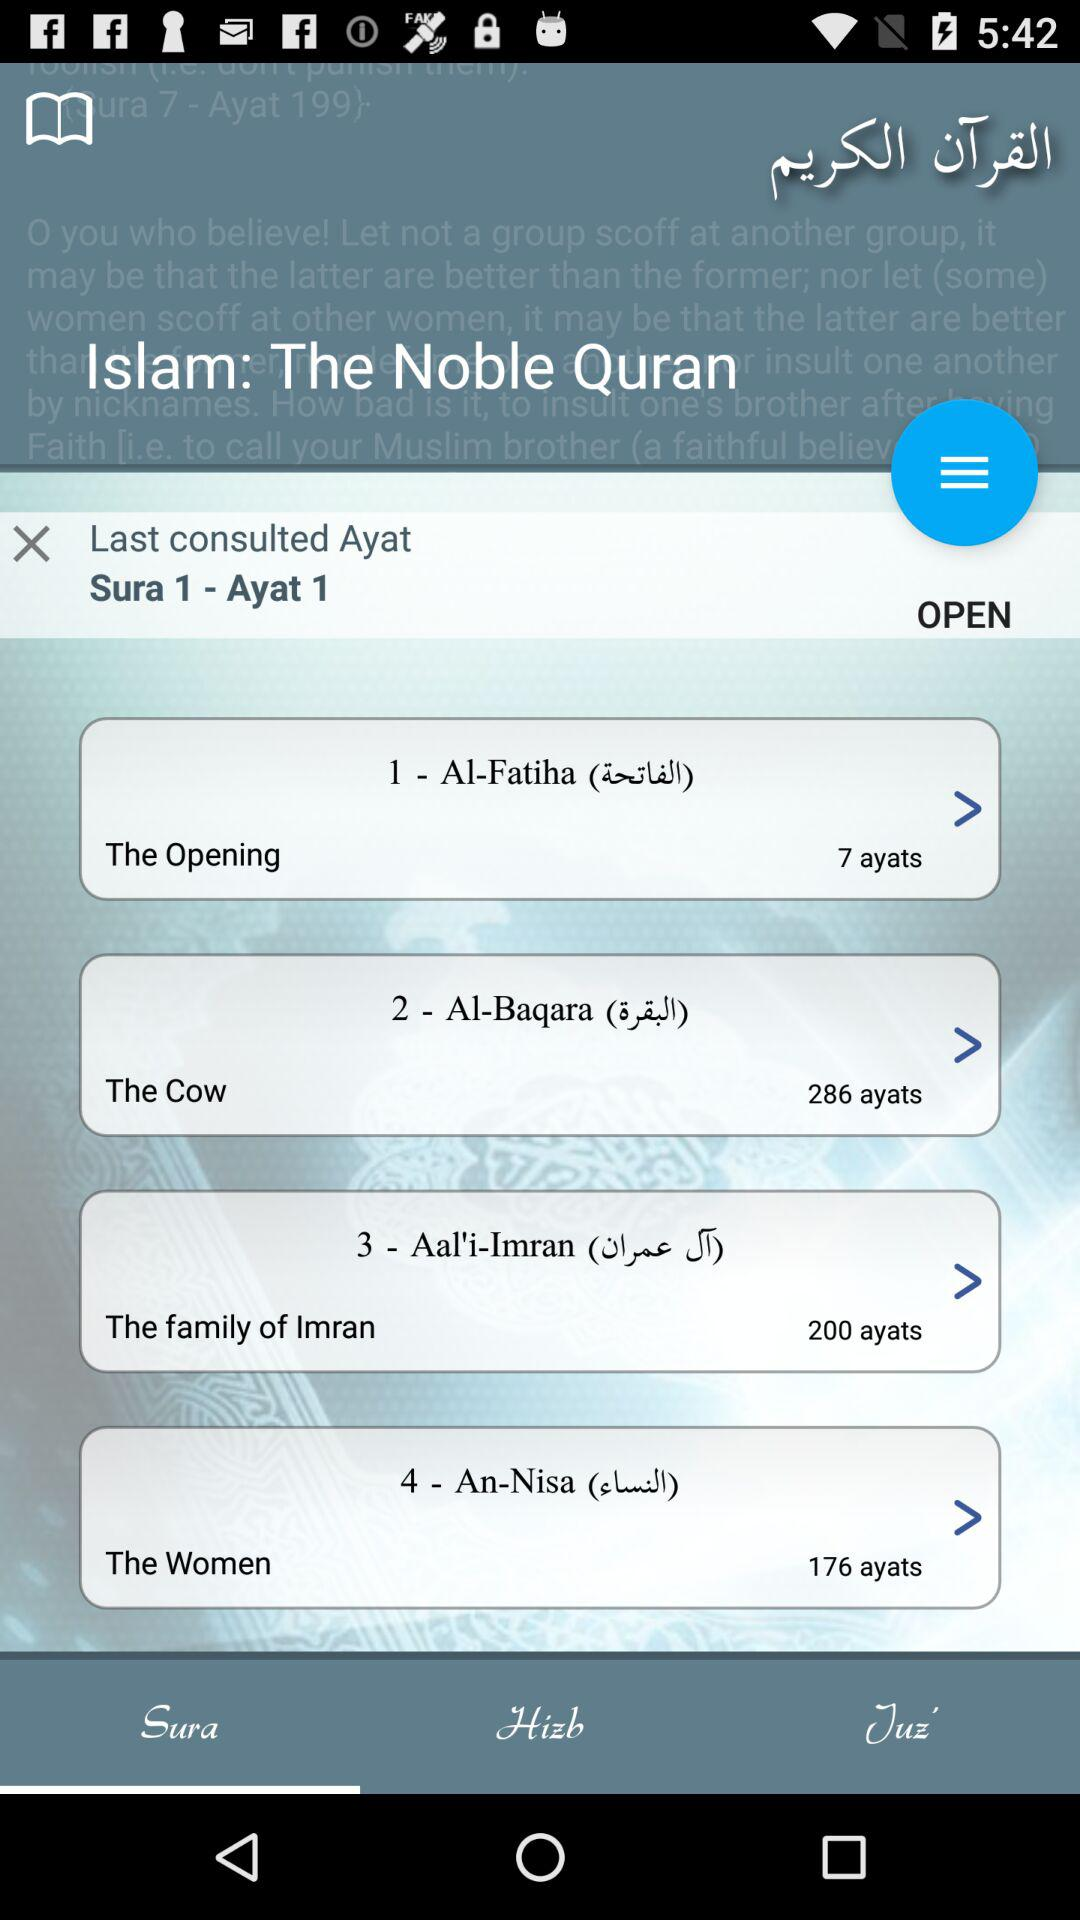How many more ayats are in Sura 2 than Sura 1?
Answer the question using a single word or phrase. 279 